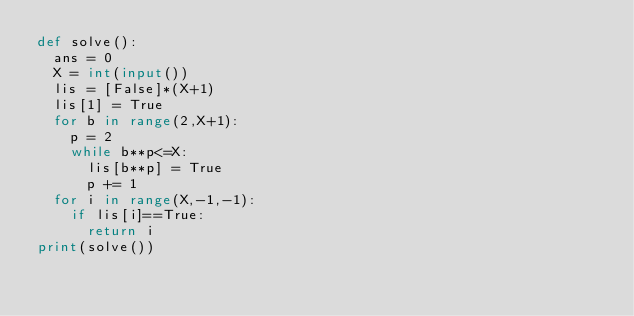Convert code to text. <code><loc_0><loc_0><loc_500><loc_500><_Python_>def solve():
  ans = 0
  X = int(input())
  lis = [False]*(X+1)
  lis[1] = True
  for b in range(2,X+1):
    p = 2
    while b**p<=X:
      lis[b**p] = True
      p += 1
  for i in range(X,-1,-1):
    if lis[i]==True:
      return i
print(solve())</code> 